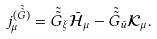Convert formula to latex. <formula><loc_0><loc_0><loc_500><loc_500>j _ { \mu } ^ { ( \tilde { \tilde { G } } ) } = \tilde { \tilde { G } } _ { \xi } \bar { \mathcal { H } } _ { \mu } - \tilde { \tilde { G } } _ { \bar { u } } \mathcal { K } _ { \mu } .</formula> 